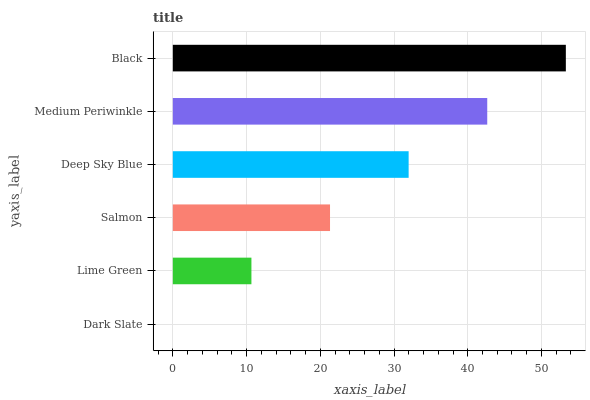Is Dark Slate the minimum?
Answer yes or no. Yes. Is Black the maximum?
Answer yes or no. Yes. Is Lime Green the minimum?
Answer yes or no. No. Is Lime Green the maximum?
Answer yes or no. No. Is Lime Green greater than Dark Slate?
Answer yes or no. Yes. Is Dark Slate less than Lime Green?
Answer yes or no. Yes. Is Dark Slate greater than Lime Green?
Answer yes or no. No. Is Lime Green less than Dark Slate?
Answer yes or no. No. Is Deep Sky Blue the high median?
Answer yes or no. Yes. Is Salmon the low median?
Answer yes or no. Yes. Is Salmon the high median?
Answer yes or no. No. Is Dark Slate the low median?
Answer yes or no. No. 